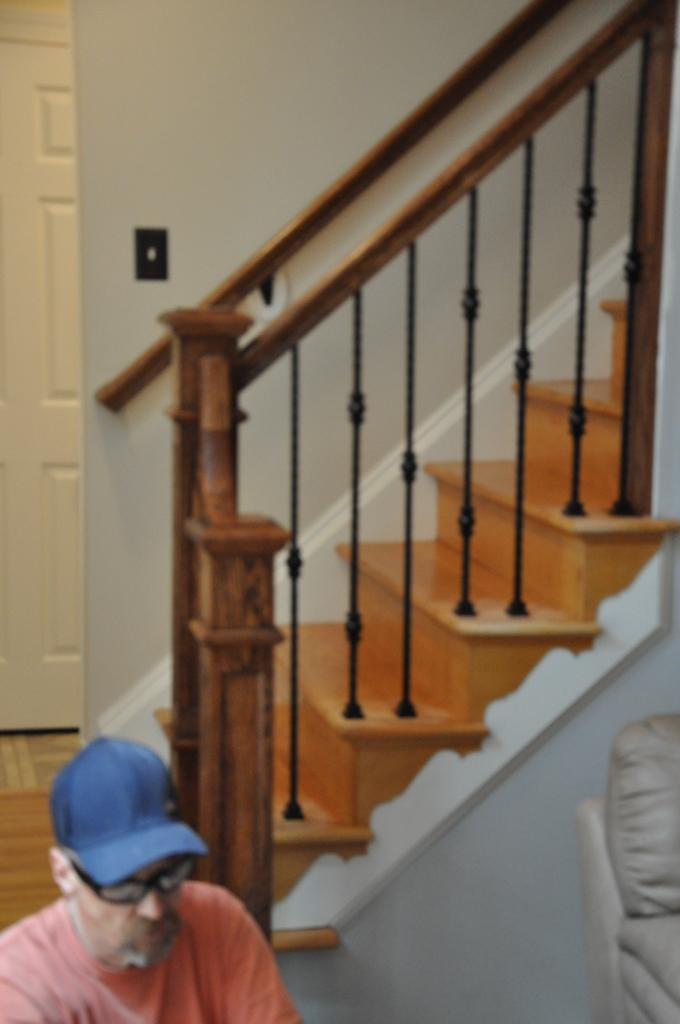What is the person in the image doing? The person is sitting in the image. Can you describe the person's attire? The person is wearing a cap. What piece of furniture is located beside the person? There is a couch beside the person. What architectural feature is visible in the image? There is a staircase visible in the image. What is the purpose of the door in the image? The door in the image provides access to another room or area. What is the function of the switch in the image? The switch in the image is likely used to control the lighting or electrical devices. How many chairs are visible in the image? There are no chairs visible in the image. What type of fiction is the person reading in the image? There is no book or any indication of reading in the image. 